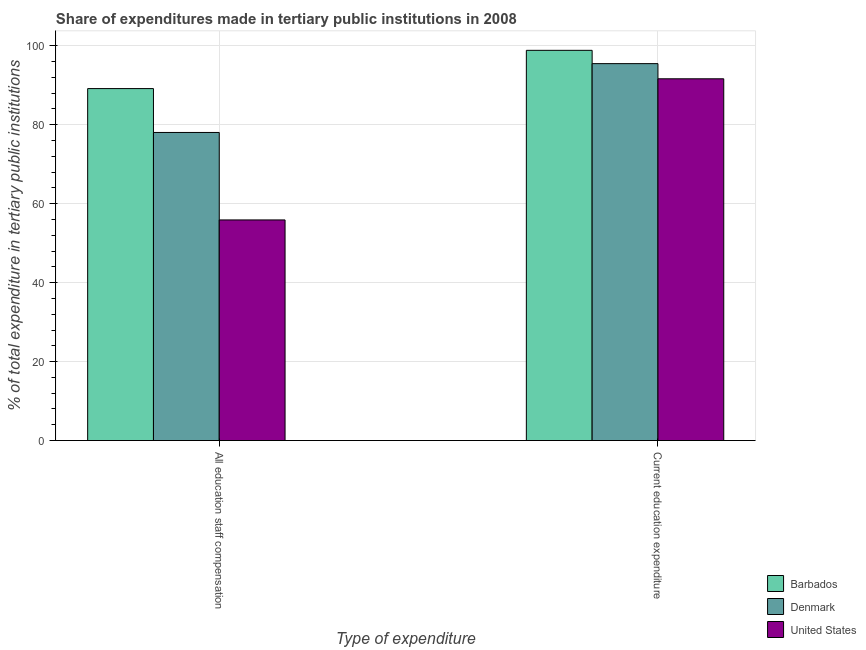How many different coloured bars are there?
Your response must be concise. 3. How many groups of bars are there?
Give a very brief answer. 2. Are the number of bars on each tick of the X-axis equal?
Your answer should be compact. Yes. How many bars are there on the 2nd tick from the left?
Keep it short and to the point. 3. How many bars are there on the 1st tick from the right?
Offer a terse response. 3. What is the label of the 2nd group of bars from the left?
Ensure brevity in your answer.  Current education expenditure. What is the expenditure in education in Barbados?
Provide a succinct answer. 98.84. Across all countries, what is the maximum expenditure in education?
Ensure brevity in your answer.  98.84. Across all countries, what is the minimum expenditure in education?
Provide a succinct answer. 91.63. In which country was the expenditure in education maximum?
Ensure brevity in your answer.  Barbados. What is the total expenditure in education in the graph?
Provide a short and direct response. 285.94. What is the difference between the expenditure in education in Denmark and that in Barbados?
Provide a succinct answer. -3.37. What is the difference between the expenditure in education in Denmark and the expenditure in staff compensation in Barbados?
Make the answer very short. 6.32. What is the average expenditure in education per country?
Keep it short and to the point. 95.31. What is the difference between the expenditure in staff compensation and expenditure in education in Barbados?
Keep it short and to the point. -9.69. What is the ratio of the expenditure in education in United States to that in Barbados?
Offer a very short reply. 0.93. What does the 2nd bar from the left in Current education expenditure represents?
Your answer should be compact. Denmark. What does the 3rd bar from the right in All education staff compensation represents?
Provide a succinct answer. Barbados. How many bars are there?
Your answer should be very brief. 6. Are all the bars in the graph horizontal?
Offer a terse response. No. How many countries are there in the graph?
Ensure brevity in your answer.  3. Are the values on the major ticks of Y-axis written in scientific E-notation?
Provide a succinct answer. No. Does the graph contain any zero values?
Offer a very short reply. No. Does the graph contain grids?
Provide a succinct answer. Yes. What is the title of the graph?
Make the answer very short. Share of expenditures made in tertiary public institutions in 2008. What is the label or title of the X-axis?
Give a very brief answer. Type of expenditure. What is the label or title of the Y-axis?
Your answer should be very brief. % of total expenditure in tertiary public institutions. What is the % of total expenditure in tertiary public institutions of Barbados in All education staff compensation?
Offer a very short reply. 89.15. What is the % of total expenditure in tertiary public institutions of Denmark in All education staff compensation?
Make the answer very short. 78.04. What is the % of total expenditure in tertiary public institutions of United States in All education staff compensation?
Keep it short and to the point. 55.88. What is the % of total expenditure in tertiary public institutions of Barbados in Current education expenditure?
Your answer should be very brief. 98.84. What is the % of total expenditure in tertiary public institutions in Denmark in Current education expenditure?
Your answer should be compact. 95.47. What is the % of total expenditure in tertiary public institutions in United States in Current education expenditure?
Ensure brevity in your answer.  91.63. Across all Type of expenditure, what is the maximum % of total expenditure in tertiary public institutions in Barbados?
Offer a terse response. 98.84. Across all Type of expenditure, what is the maximum % of total expenditure in tertiary public institutions in Denmark?
Your answer should be compact. 95.47. Across all Type of expenditure, what is the maximum % of total expenditure in tertiary public institutions of United States?
Your response must be concise. 91.63. Across all Type of expenditure, what is the minimum % of total expenditure in tertiary public institutions of Barbados?
Make the answer very short. 89.15. Across all Type of expenditure, what is the minimum % of total expenditure in tertiary public institutions of Denmark?
Provide a short and direct response. 78.04. Across all Type of expenditure, what is the minimum % of total expenditure in tertiary public institutions in United States?
Give a very brief answer. 55.88. What is the total % of total expenditure in tertiary public institutions in Barbados in the graph?
Offer a very short reply. 187.99. What is the total % of total expenditure in tertiary public institutions of Denmark in the graph?
Offer a very short reply. 173.51. What is the total % of total expenditure in tertiary public institutions of United States in the graph?
Your answer should be compact. 147.52. What is the difference between the % of total expenditure in tertiary public institutions in Barbados in All education staff compensation and that in Current education expenditure?
Make the answer very short. -9.69. What is the difference between the % of total expenditure in tertiary public institutions in Denmark in All education staff compensation and that in Current education expenditure?
Provide a succinct answer. -17.43. What is the difference between the % of total expenditure in tertiary public institutions of United States in All education staff compensation and that in Current education expenditure?
Offer a terse response. -35.75. What is the difference between the % of total expenditure in tertiary public institutions of Barbados in All education staff compensation and the % of total expenditure in tertiary public institutions of Denmark in Current education expenditure?
Offer a terse response. -6.32. What is the difference between the % of total expenditure in tertiary public institutions in Barbados in All education staff compensation and the % of total expenditure in tertiary public institutions in United States in Current education expenditure?
Make the answer very short. -2.48. What is the difference between the % of total expenditure in tertiary public institutions of Denmark in All education staff compensation and the % of total expenditure in tertiary public institutions of United States in Current education expenditure?
Keep it short and to the point. -13.59. What is the average % of total expenditure in tertiary public institutions of Barbados per Type of expenditure?
Keep it short and to the point. 94. What is the average % of total expenditure in tertiary public institutions in Denmark per Type of expenditure?
Ensure brevity in your answer.  86.75. What is the average % of total expenditure in tertiary public institutions in United States per Type of expenditure?
Offer a very short reply. 73.76. What is the difference between the % of total expenditure in tertiary public institutions of Barbados and % of total expenditure in tertiary public institutions of Denmark in All education staff compensation?
Your answer should be very brief. 11.11. What is the difference between the % of total expenditure in tertiary public institutions of Barbados and % of total expenditure in tertiary public institutions of United States in All education staff compensation?
Your response must be concise. 33.27. What is the difference between the % of total expenditure in tertiary public institutions in Denmark and % of total expenditure in tertiary public institutions in United States in All education staff compensation?
Give a very brief answer. 22.15. What is the difference between the % of total expenditure in tertiary public institutions in Barbados and % of total expenditure in tertiary public institutions in Denmark in Current education expenditure?
Offer a very short reply. 3.37. What is the difference between the % of total expenditure in tertiary public institutions of Barbados and % of total expenditure in tertiary public institutions of United States in Current education expenditure?
Ensure brevity in your answer.  7.21. What is the difference between the % of total expenditure in tertiary public institutions of Denmark and % of total expenditure in tertiary public institutions of United States in Current education expenditure?
Keep it short and to the point. 3.84. What is the ratio of the % of total expenditure in tertiary public institutions of Barbados in All education staff compensation to that in Current education expenditure?
Give a very brief answer. 0.9. What is the ratio of the % of total expenditure in tertiary public institutions in Denmark in All education staff compensation to that in Current education expenditure?
Make the answer very short. 0.82. What is the ratio of the % of total expenditure in tertiary public institutions in United States in All education staff compensation to that in Current education expenditure?
Make the answer very short. 0.61. What is the difference between the highest and the second highest % of total expenditure in tertiary public institutions of Barbados?
Your answer should be very brief. 9.69. What is the difference between the highest and the second highest % of total expenditure in tertiary public institutions in Denmark?
Your answer should be compact. 17.43. What is the difference between the highest and the second highest % of total expenditure in tertiary public institutions in United States?
Give a very brief answer. 35.75. What is the difference between the highest and the lowest % of total expenditure in tertiary public institutions of Barbados?
Provide a succinct answer. 9.69. What is the difference between the highest and the lowest % of total expenditure in tertiary public institutions of Denmark?
Make the answer very short. 17.43. What is the difference between the highest and the lowest % of total expenditure in tertiary public institutions in United States?
Offer a terse response. 35.75. 